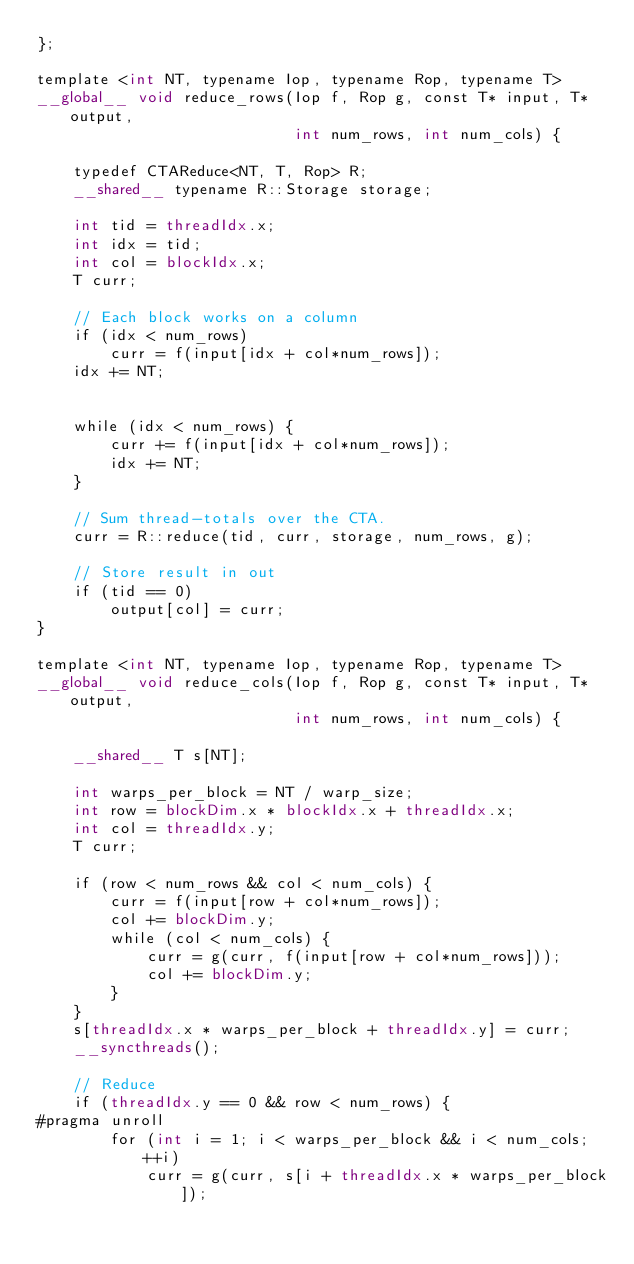<code> <loc_0><loc_0><loc_500><loc_500><_Cuda_>};

template <int NT, typename Iop, typename Rop, typename T>
__global__ void reduce_rows(Iop f, Rop g, const T* input, T* output,
                            int num_rows, int num_cols) {

    typedef CTAReduce<NT, T, Rop> R;
    __shared__ typename R::Storage storage;

    int tid = threadIdx.x;
    int idx = tid;
    int col = blockIdx.x;
    T curr;

    // Each block works on a column
    if (idx < num_rows)
        curr = f(input[idx + col*num_rows]);
    idx += NT;


    while (idx < num_rows) {
        curr += f(input[idx + col*num_rows]);
        idx += NT;
    }

    // Sum thread-totals over the CTA.
    curr = R::reduce(tid, curr, storage, num_rows, g);

    // Store result in out
    if (tid == 0)
        output[col] = curr;
}

template <int NT, typename Iop, typename Rop, typename T>
__global__ void reduce_cols(Iop f, Rop g, const T* input, T* output,
                            int num_rows, int num_cols) {

    __shared__ T s[NT];

    int warps_per_block = NT / warp_size;
    int row = blockDim.x * blockIdx.x + threadIdx.x;
    int col = threadIdx.y;
    T curr;

    if (row < num_rows && col < num_cols) {
        curr = f(input[row + col*num_rows]);
        col += blockDim.y;
        while (col < num_cols) {
            curr = g(curr, f(input[row + col*num_rows]));
            col += blockDim.y;
        }
    }
    s[threadIdx.x * warps_per_block + threadIdx.y] = curr;
    __syncthreads();

    // Reduce
    if (threadIdx.y == 0 && row < num_rows) {
#pragma unroll
        for (int i = 1; i < warps_per_block && i < num_cols; ++i)
            curr = g(curr, s[i + threadIdx.x * warps_per_block]);</code> 